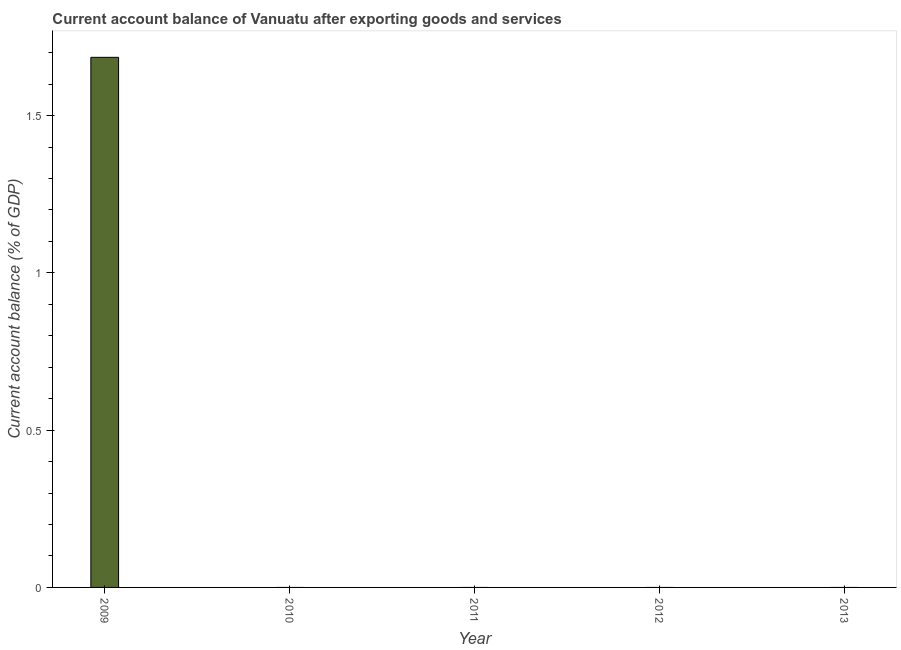What is the title of the graph?
Offer a terse response. Current account balance of Vanuatu after exporting goods and services. What is the label or title of the Y-axis?
Offer a very short reply. Current account balance (% of GDP). What is the current account balance in 2012?
Give a very brief answer. 0. Across all years, what is the maximum current account balance?
Ensure brevity in your answer.  1.69. Across all years, what is the minimum current account balance?
Make the answer very short. 0. In which year was the current account balance maximum?
Provide a short and direct response. 2009. What is the sum of the current account balance?
Your response must be concise. 1.69. What is the average current account balance per year?
Ensure brevity in your answer.  0.34. What is the difference between the highest and the lowest current account balance?
Give a very brief answer. 1.69. In how many years, is the current account balance greater than the average current account balance taken over all years?
Make the answer very short. 1. How many years are there in the graph?
Provide a short and direct response. 5. What is the difference between two consecutive major ticks on the Y-axis?
Make the answer very short. 0.5. What is the Current account balance (% of GDP) in 2009?
Your answer should be very brief. 1.69. What is the Current account balance (% of GDP) of 2012?
Provide a succinct answer. 0. 